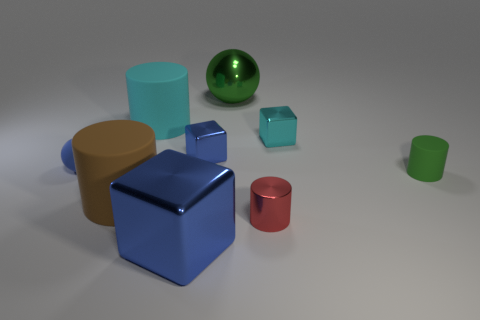Is there a green rubber object of the same shape as the brown rubber thing?
Make the answer very short. Yes. There is a big green metallic object; is it the same shape as the rubber thing that is left of the large brown object?
Your answer should be compact. Yes. How big is the cylinder that is behind the brown cylinder and right of the large cyan cylinder?
Give a very brief answer. Small. How many red metal things are there?
Your answer should be very brief. 1. What material is the green cylinder that is the same size as the red metallic cylinder?
Keep it short and to the point. Rubber. Are there any cyan rubber things of the same size as the green shiny object?
Provide a short and direct response. Yes. There is a tiny rubber thing that is to the left of the large cyan matte cylinder; is its color the same as the small metal cube that is to the left of the big green shiny object?
Offer a terse response. Yes. How many shiny things are tiny blue cylinders or blocks?
Offer a terse response. 3. There is a blue metal cube that is in front of the small matte object on the left side of the red cylinder; how many cubes are behind it?
Ensure brevity in your answer.  2. There is a red cylinder that is the same material as the tiny blue cube; what size is it?
Your answer should be very brief. Small. 